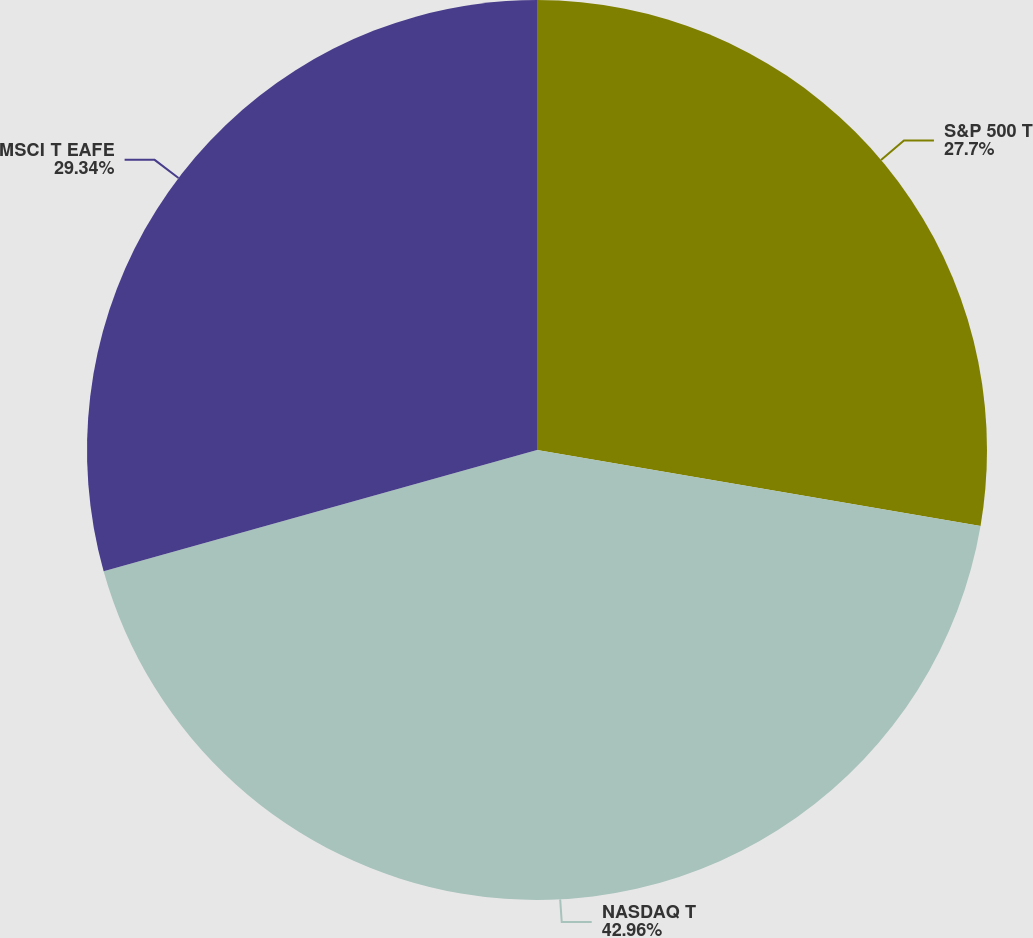<chart> <loc_0><loc_0><loc_500><loc_500><pie_chart><fcel>S&P 500 T<fcel>NASDAQ T<fcel>MSCI T EAFE<nl><fcel>27.7%<fcel>42.96%<fcel>29.34%<nl></chart> 